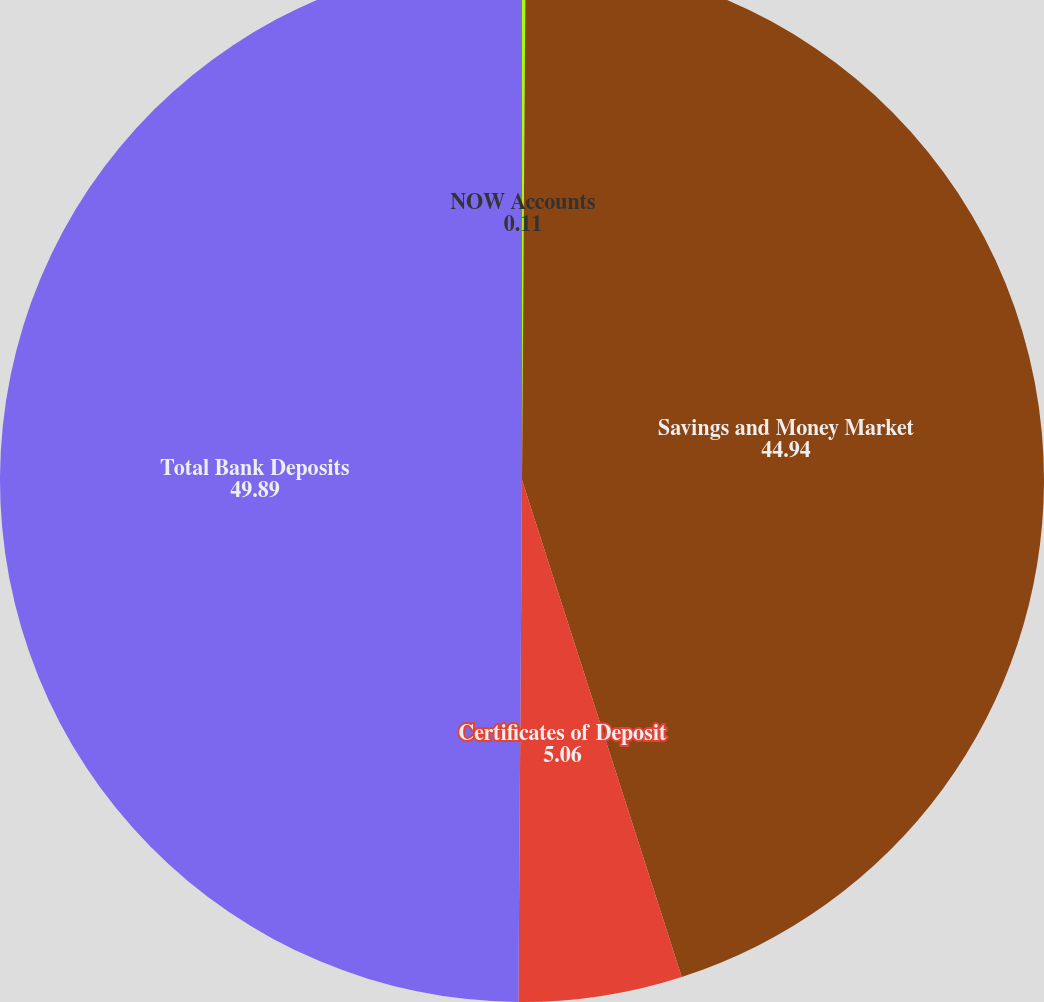<chart> <loc_0><loc_0><loc_500><loc_500><pie_chart><fcel>NOW Accounts<fcel>Savings and Money Market<fcel>Certificates of Deposit<fcel>Total Bank Deposits<nl><fcel>0.11%<fcel>44.94%<fcel>5.06%<fcel>49.89%<nl></chart> 